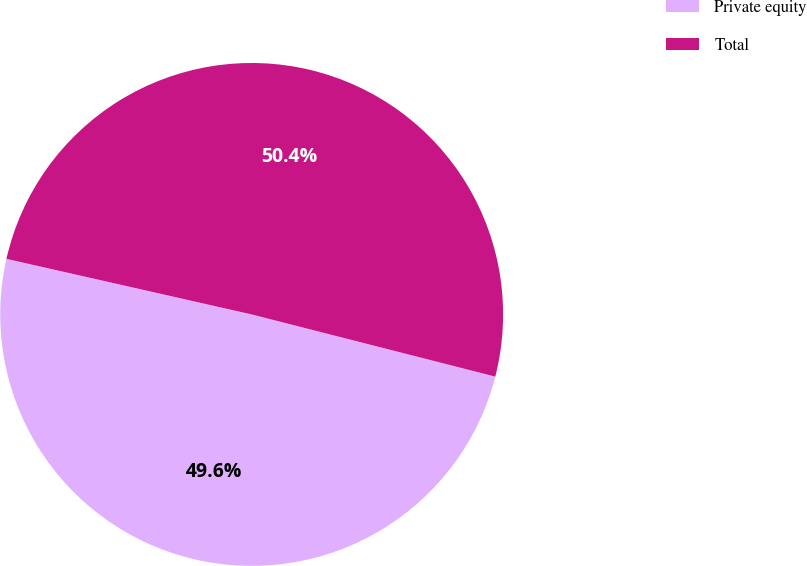Convert chart to OTSL. <chart><loc_0><loc_0><loc_500><loc_500><pie_chart><fcel>Private equity<fcel>Total<nl><fcel>49.57%<fcel>50.43%<nl></chart> 